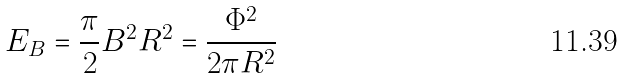<formula> <loc_0><loc_0><loc_500><loc_500>E _ { B } = \frac { \pi } { 2 } B ^ { 2 } R ^ { 2 } = \frac { \Phi ^ { 2 } } { 2 \pi R ^ { 2 } }</formula> 